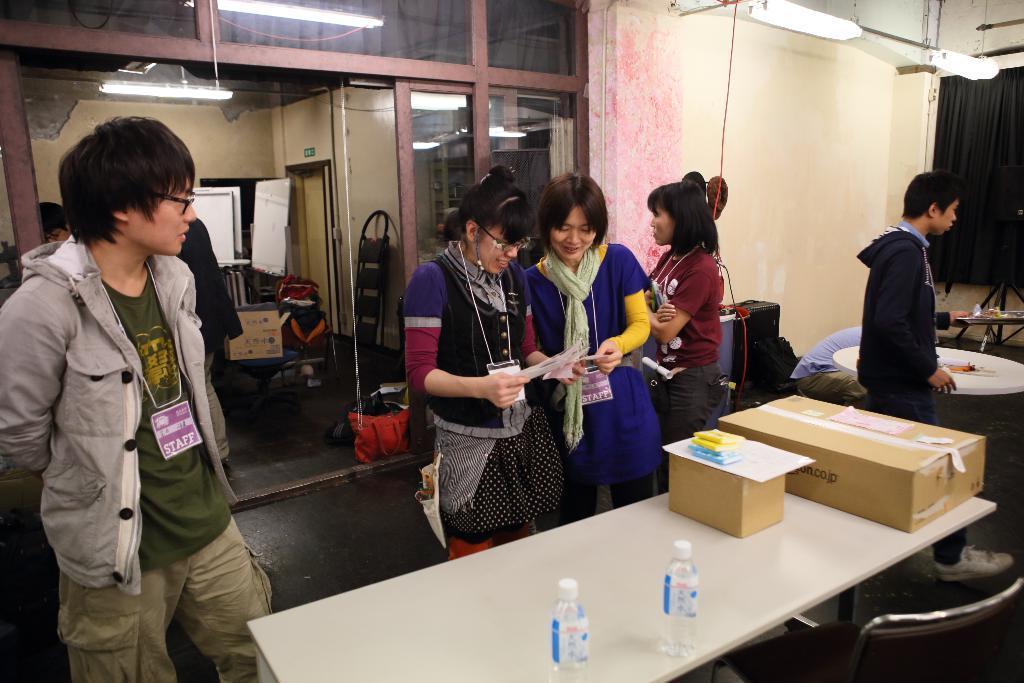Could you give a brief overview of what you see in this image? In this image I can see a person wearing green t shirt, grey jacket is standing and two other women are standing and holding few papers in their hands in front of a table which is white in color and on the table I can see few water bottles, few cardboard boxes and few other objects. In the background I can see few other persons standing, a person sitting, the wall, the glass doors, few lights and the black colored curtain. 